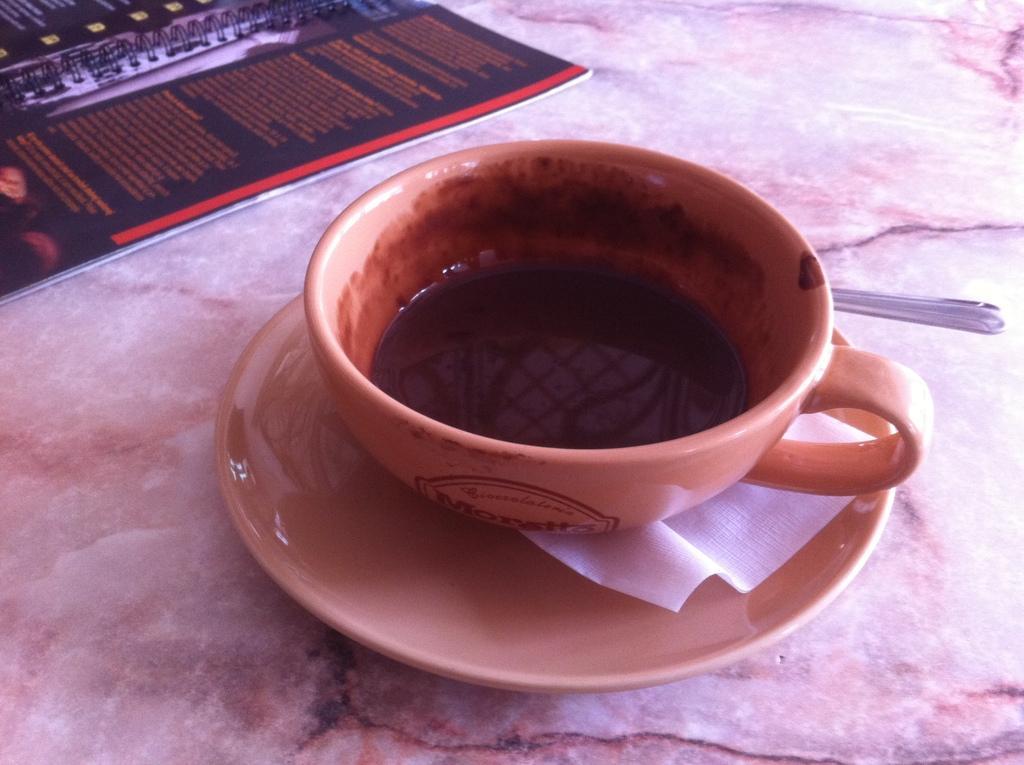Could you give a brief overview of what you see in this image? In the picture I can see a cup with a drink in it is placed on the saucer, here we can see a tissue and a spoon which are all placed on the marble surface. Here we can see a menu card. 